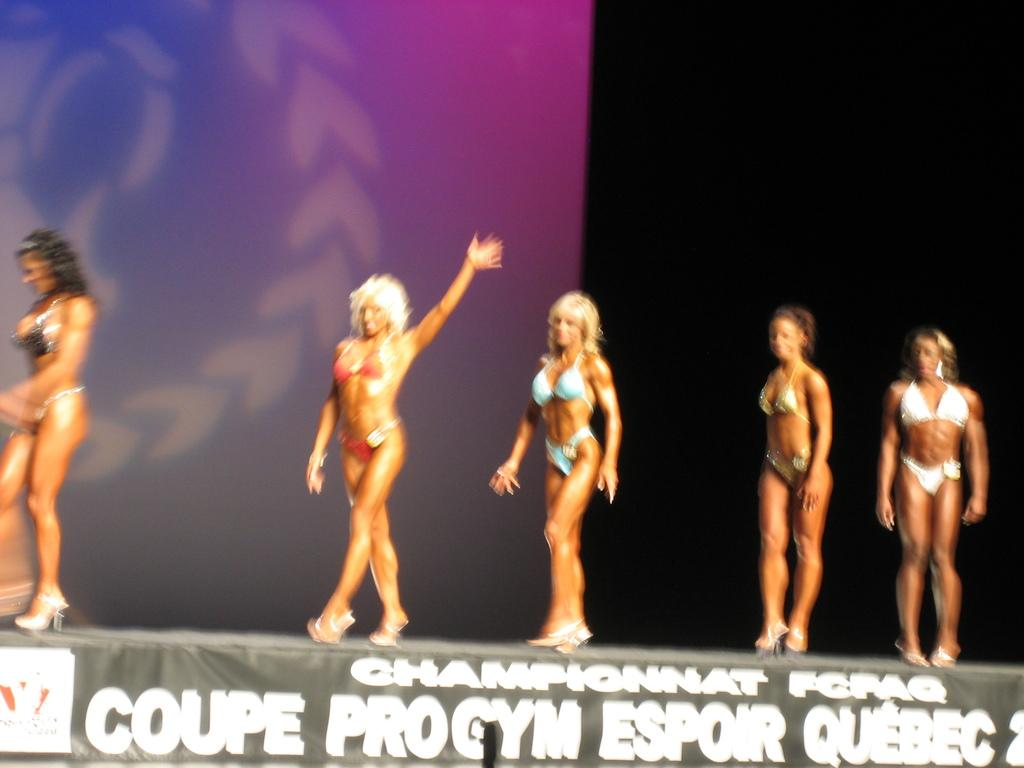How many women are present in the image? There are five women in the image. What are the women doing in the image? The women are walking on a dais. What can be seen in the background of the image? There is a screen in the background of the image. What is written or displayed at the bottom of the image? There is text at the bottom of the image. What type of hose is being used by the women in the image? There is no hose present in the image; the women are walking on a dais. What type of cloth is draped over the screen in the background? There is no cloth draped over the screen in the background; the screen is visible without any covering. 